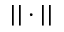Convert formula to latex. <formula><loc_0><loc_0><loc_500><loc_500>| | \cdot | |</formula> 